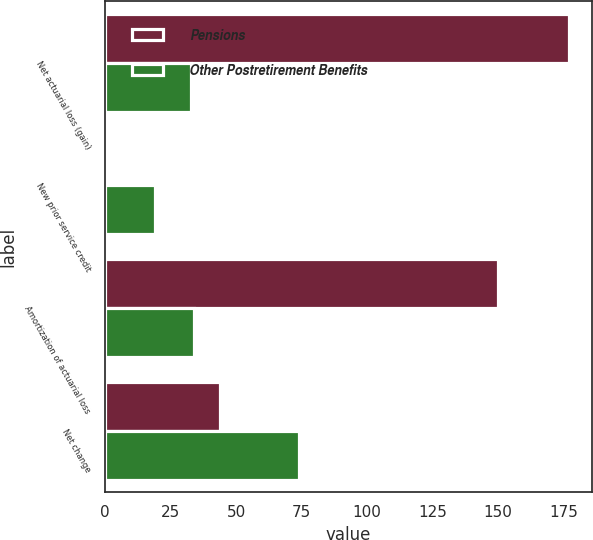<chart> <loc_0><loc_0><loc_500><loc_500><stacked_bar_chart><ecel><fcel>Net actuarial loss (gain)<fcel>New prior service credit<fcel>Amortization of actuarial loss<fcel>Net change<nl><fcel>Pensions<fcel>177<fcel>1<fcel>150<fcel>44<nl><fcel>Other Postretirement Benefits<fcel>33<fcel>19<fcel>34<fcel>74<nl></chart> 